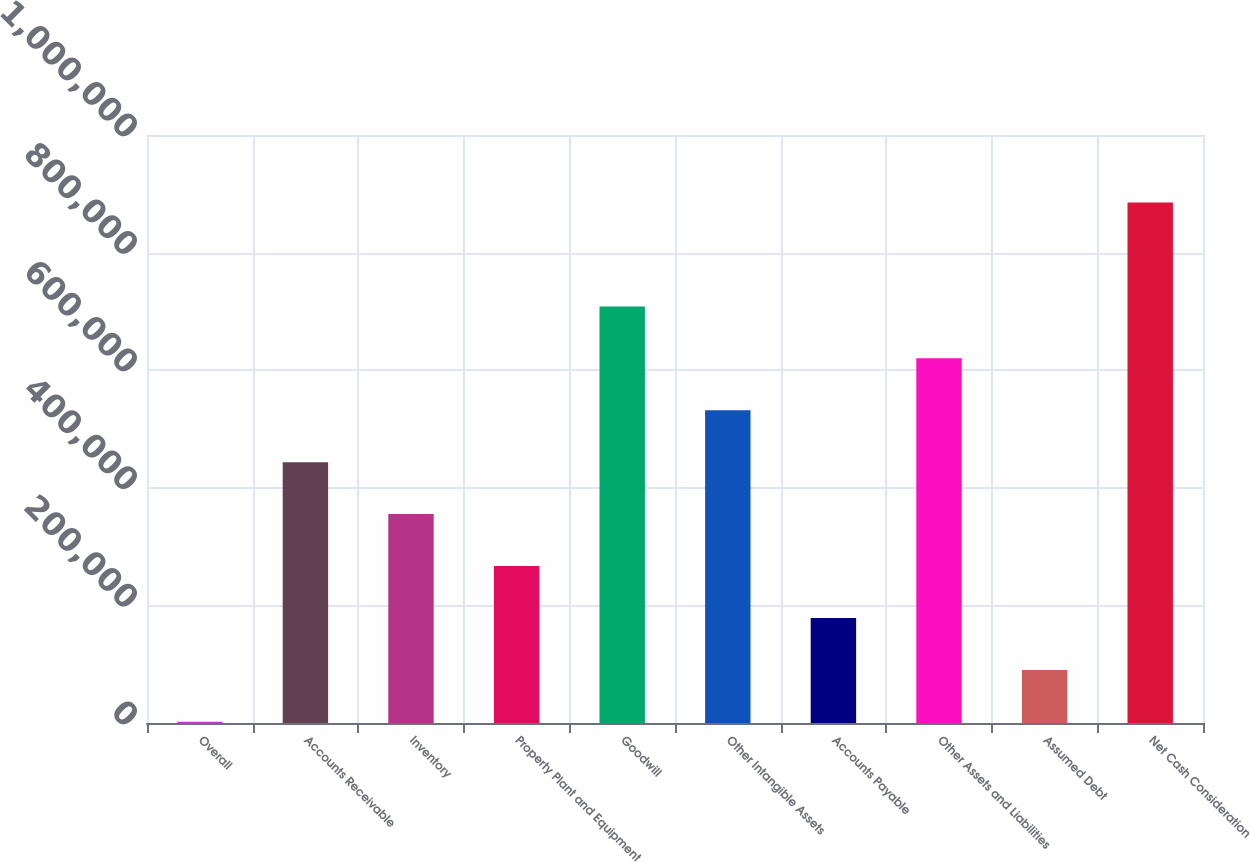<chart> <loc_0><loc_0><loc_500><loc_500><bar_chart><fcel>Overall<fcel>Accounts Receivable<fcel>Inventory<fcel>Property Plant and Equipment<fcel>Goodwill<fcel>Other Intangible Assets<fcel>Accounts Payable<fcel>Other Assets and Liabilities<fcel>Assumed Debt<fcel>Net Cash Consideration<nl><fcel>2005<fcel>443544<fcel>355236<fcel>266928<fcel>708467<fcel>531852<fcel>178621<fcel>620160<fcel>90312.8<fcel>885083<nl></chart> 